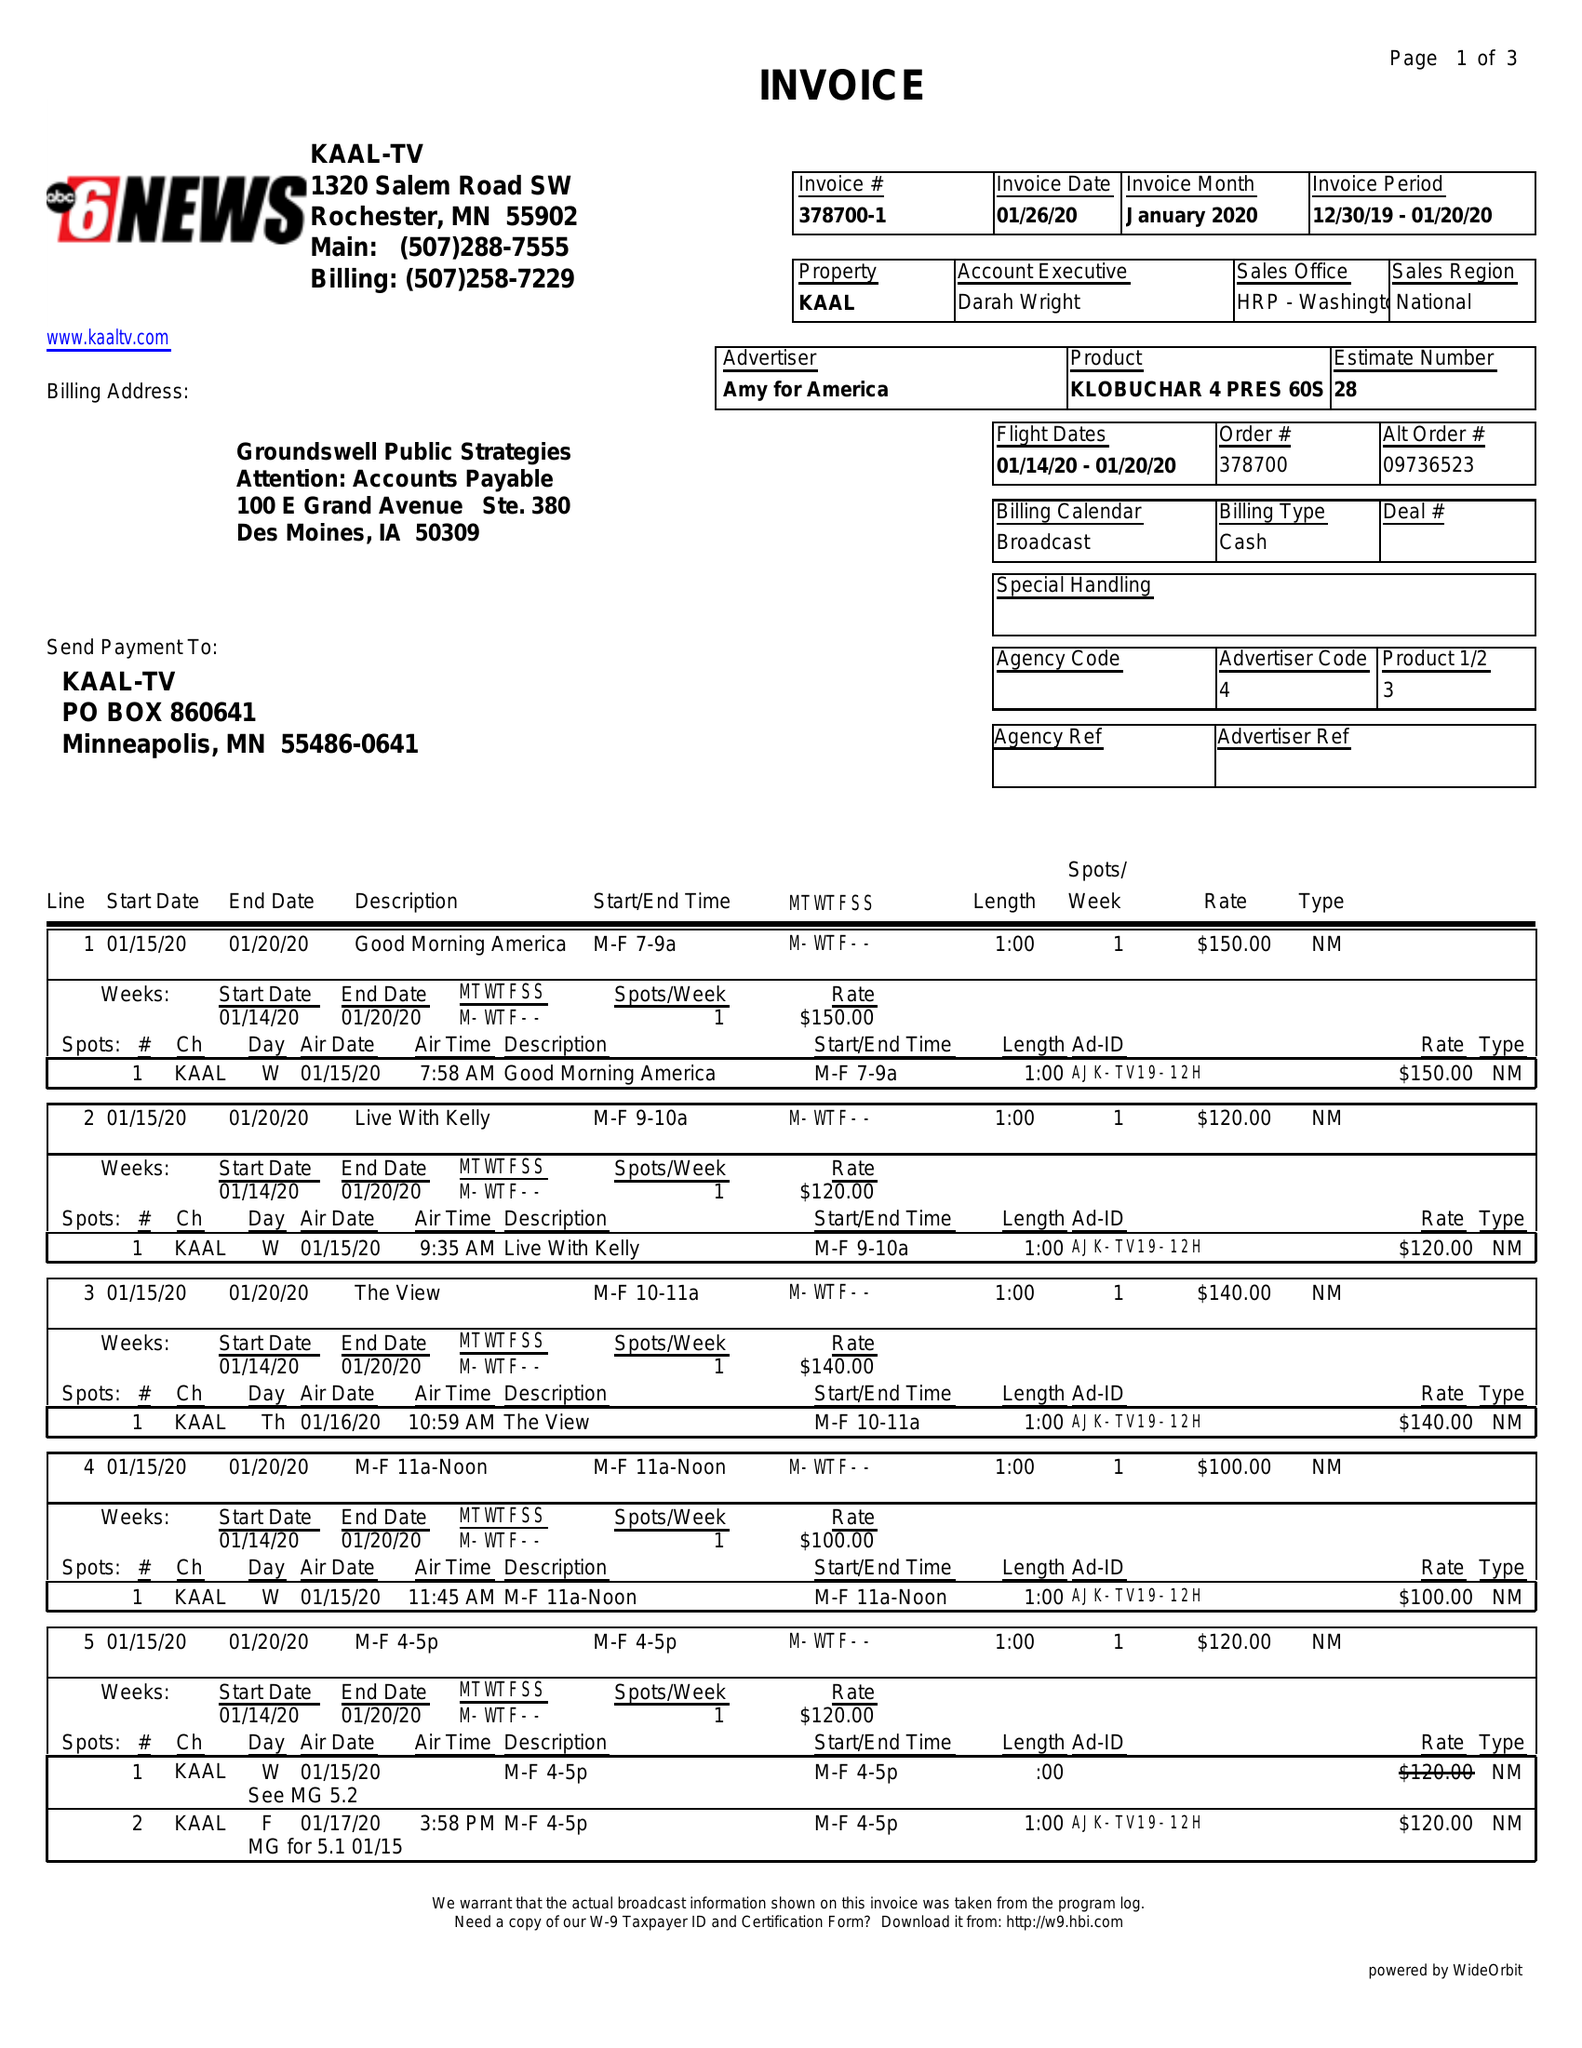What is the value for the flight_from?
Answer the question using a single word or phrase. 01/14/20 